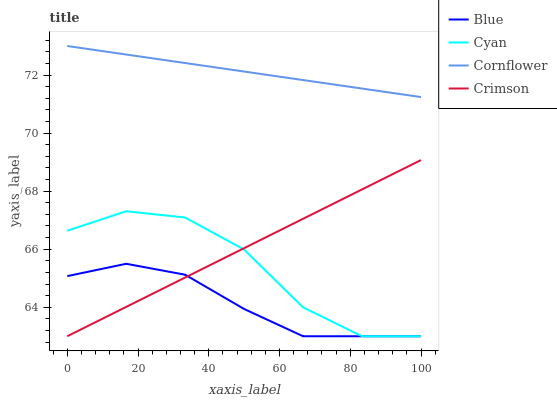Does Blue have the minimum area under the curve?
Answer yes or no. Yes. Does Cornflower have the maximum area under the curve?
Answer yes or no. Yes. Does Cyan have the minimum area under the curve?
Answer yes or no. No. Does Cyan have the maximum area under the curve?
Answer yes or no. No. Is Cornflower the smoothest?
Answer yes or no. Yes. Is Cyan the roughest?
Answer yes or no. Yes. Is Crimson the smoothest?
Answer yes or no. No. Is Crimson the roughest?
Answer yes or no. No. Does Blue have the lowest value?
Answer yes or no. Yes. Does Cornflower have the lowest value?
Answer yes or no. No. Does Cornflower have the highest value?
Answer yes or no. Yes. Does Cyan have the highest value?
Answer yes or no. No. Is Cyan less than Cornflower?
Answer yes or no. Yes. Is Cornflower greater than Blue?
Answer yes or no. Yes. Does Cyan intersect Crimson?
Answer yes or no. Yes. Is Cyan less than Crimson?
Answer yes or no. No. Is Cyan greater than Crimson?
Answer yes or no. No. Does Cyan intersect Cornflower?
Answer yes or no. No. 